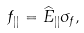<formula> <loc_0><loc_0><loc_500><loc_500>f _ { | | } = \widehat { E } _ { | | } \sigma _ { f } ,</formula> 